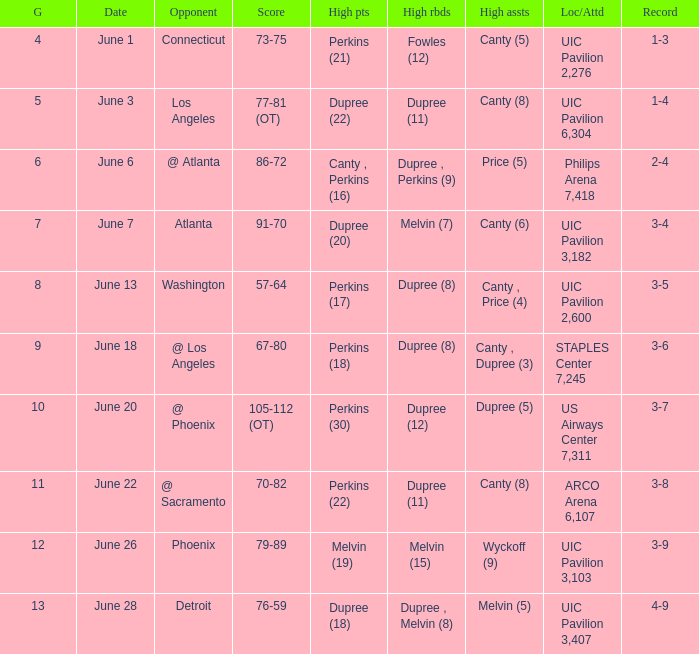What is the date of game 9? June 18. 